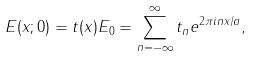<formula> <loc_0><loc_0><loc_500><loc_500>E ( x ; 0 ) = t ( x ) E _ { 0 } = \sum _ { n = - \infty } ^ { \infty } t _ { n } e ^ { 2 \pi i n x / a } ,</formula> 